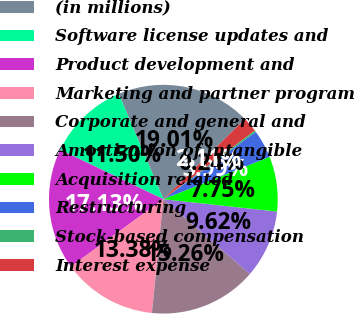Convert chart to OTSL. <chart><loc_0><loc_0><loc_500><loc_500><pie_chart><fcel>(in millions)<fcel>Software license updates and<fcel>Product development and<fcel>Marketing and partner program<fcel>Corporate and general and<fcel>Amortization of intangible<fcel>Acquisition related<fcel>Restructuring<fcel>Stock-based compensation<fcel>Interest expense<nl><fcel>19.01%<fcel>11.5%<fcel>17.13%<fcel>13.38%<fcel>15.26%<fcel>9.62%<fcel>7.75%<fcel>3.99%<fcel>0.24%<fcel>2.11%<nl></chart> 